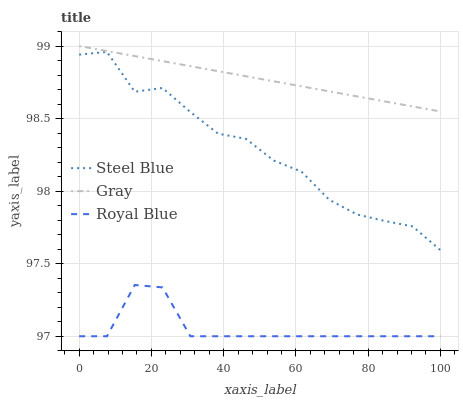Does Royal Blue have the minimum area under the curve?
Answer yes or no. Yes. Does Gray have the maximum area under the curve?
Answer yes or no. Yes. Does Steel Blue have the minimum area under the curve?
Answer yes or no. No. Does Steel Blue have the maximum area under the curve?
Answer yes or no. No. Is Gray the smoothest?
Answer yes or no. Yes. Is Steel Blue the roughest?
Answer yes or no. Yes. Is Royal Blue the smoothest?
Answer yes or no. No. Is Royal Blue the roughest?
Answer yes or no. No. Does Steel Blue have the lowest value?
Answer yes or no. No. Does Steel Blue have the highest value?
Answer yes or no. No. Is Royal Blue less than Steel Blue?
Answer yes or no. Yes. Is Gray greater than Royal Blue?
Answer yes or no. Yes. Does Royal Blue intersect Steel Blue?
Answer yes or no. No. 